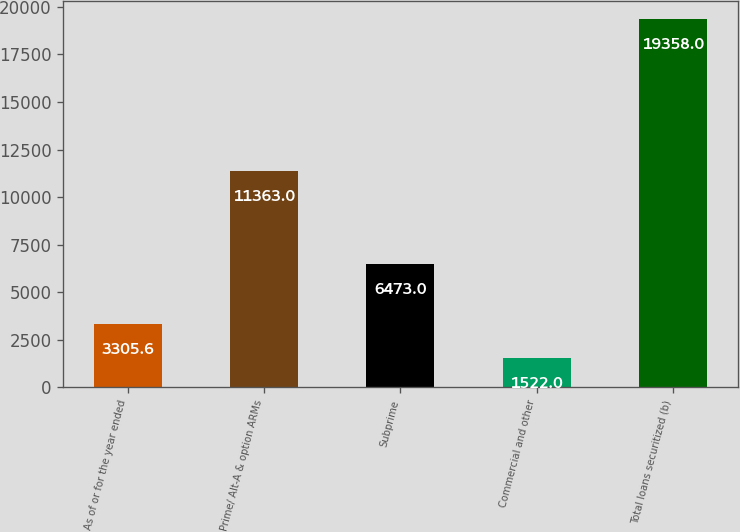Convert chart to OTSL. <chart><loc_0><loc_0><loc_500><loc_500><bar_chart><fcel>As of or for the year ended<fcel>Prime/ Alt-A & option ARMs<fcel>Subprime<fcel>Commercial and other<fcel>Total loans securitized (b)<nl><fcel>3305.6<fcel>11363<fcel>6473<fcel>1522<fcel>19358<nl></chart> 